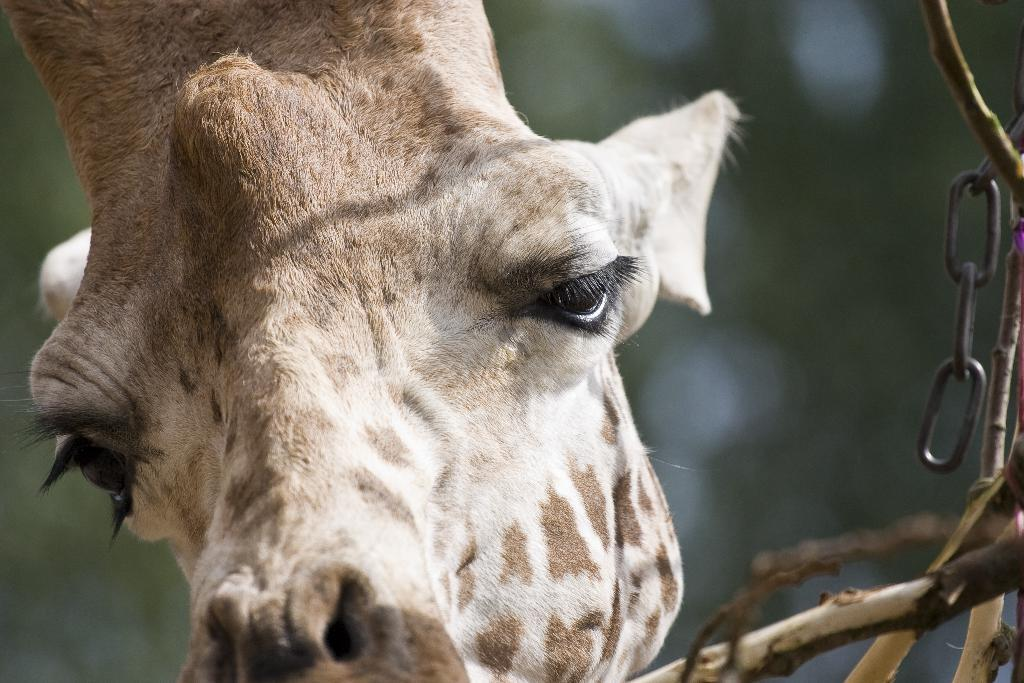What type of animal is in the image? There is a giraffe in the image. What object can be seen on the right side of the image? There is a chain on the right side of the image. What else is present in the image besides the giraffe and the chain? There are stems in the image. What type of dust can be seen accumulating on the giraffe's fur in the image? There is no dust present in the image; the giraffe's fur appears clean. What type of cloud can be seen in the background of the image? There is no cloud visible in the image; it is focused on the giraffe and the chain. 